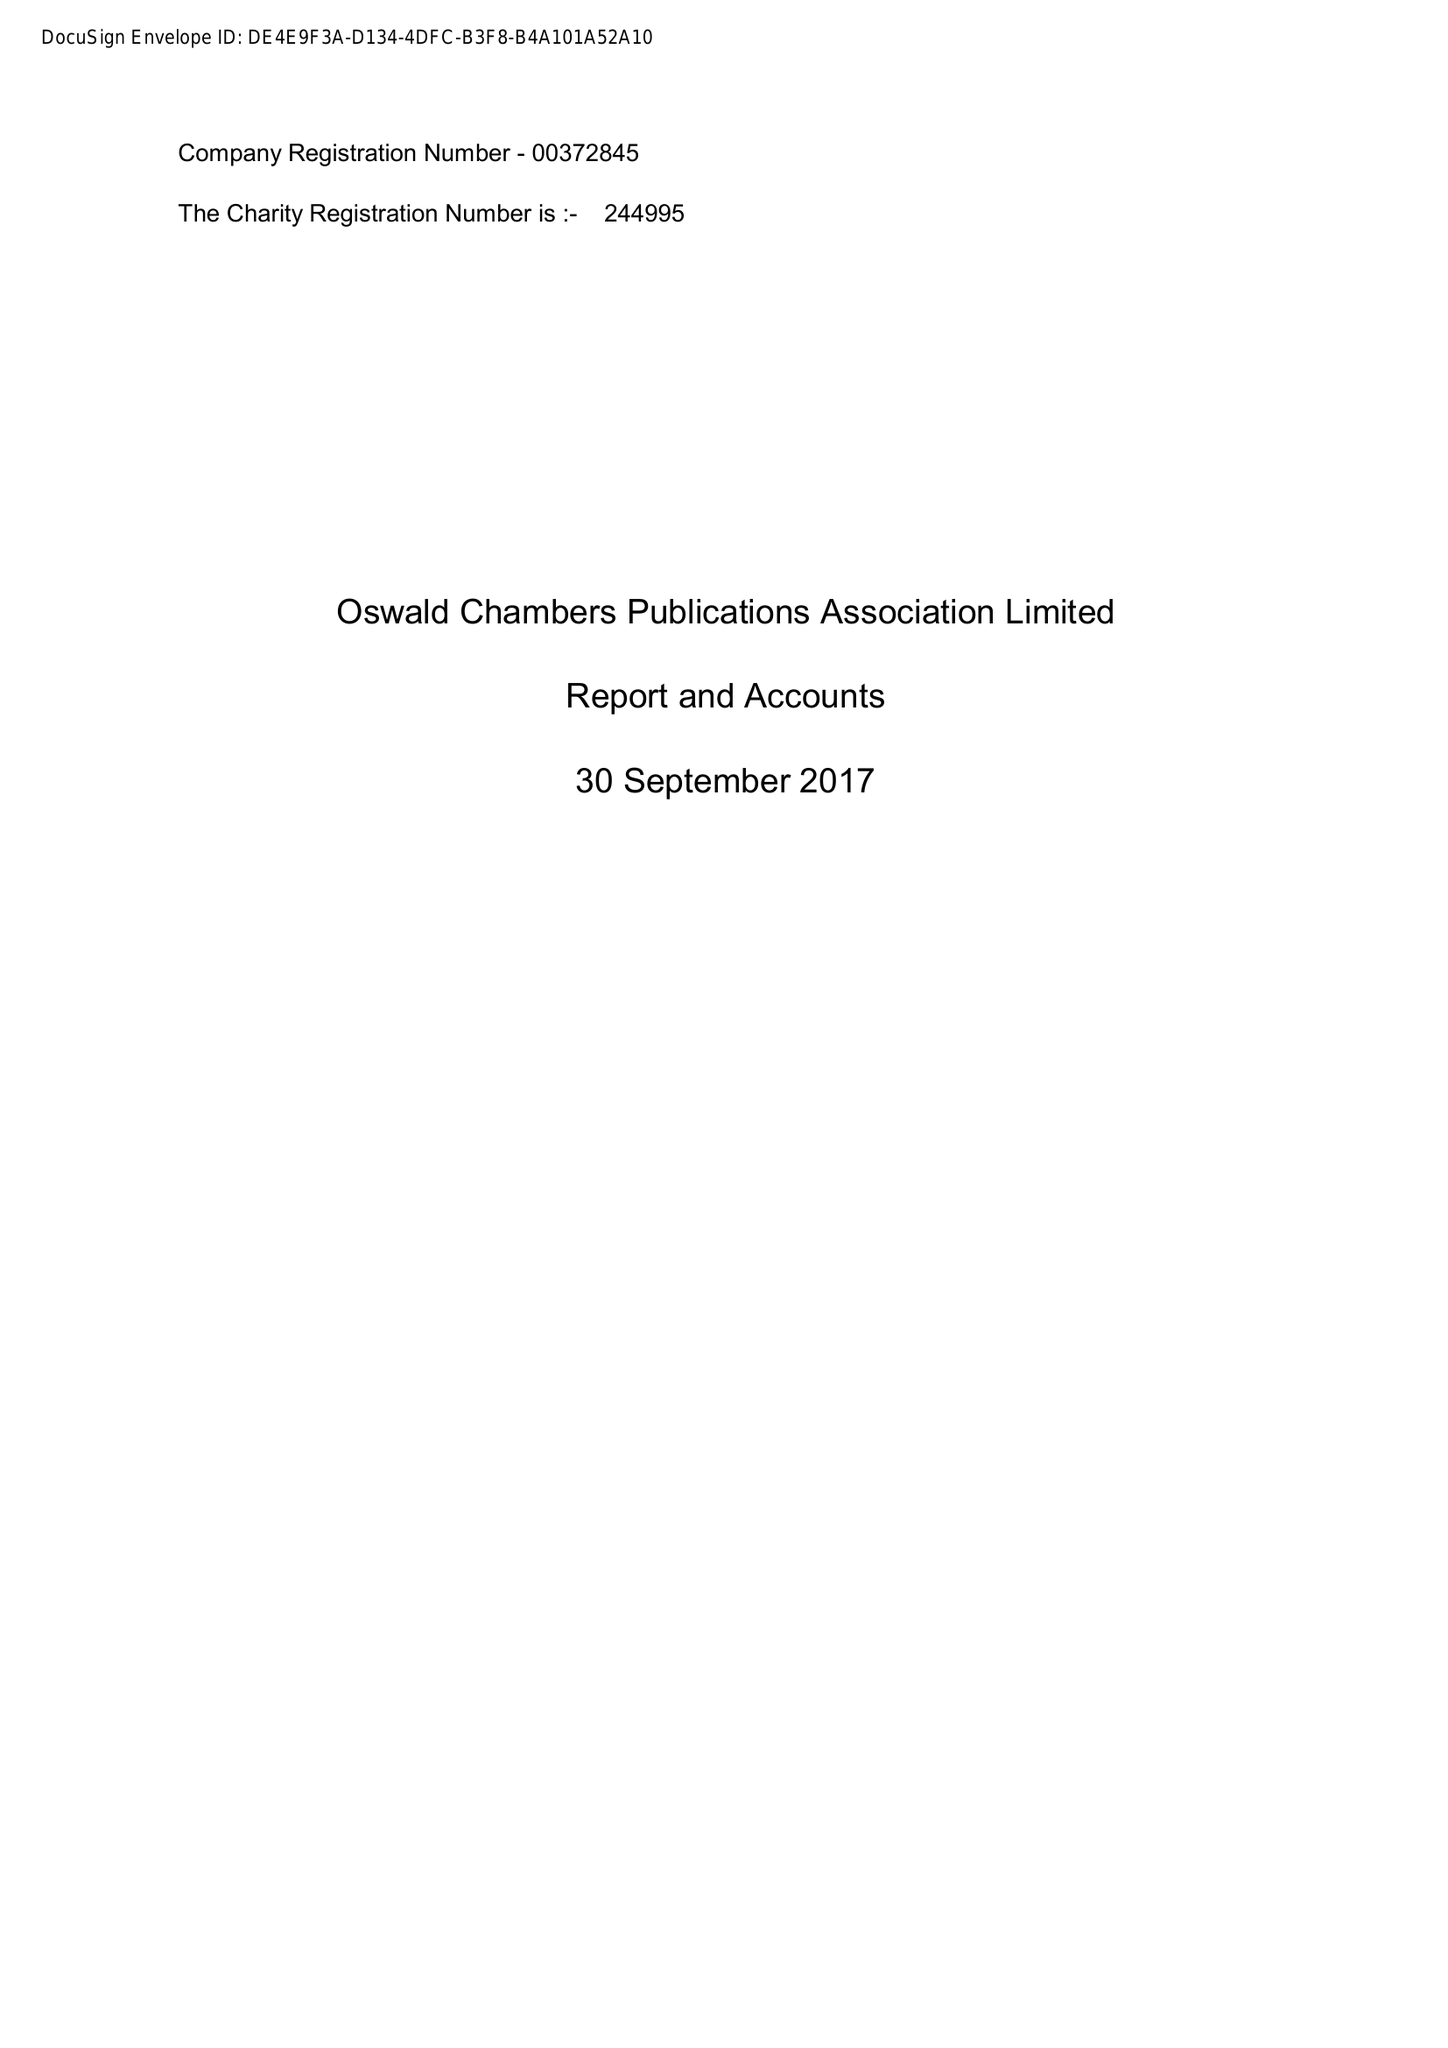What is the value for the income_annually_in_british_pounds?
Answer the question using a single word or phrase. 53077.00 